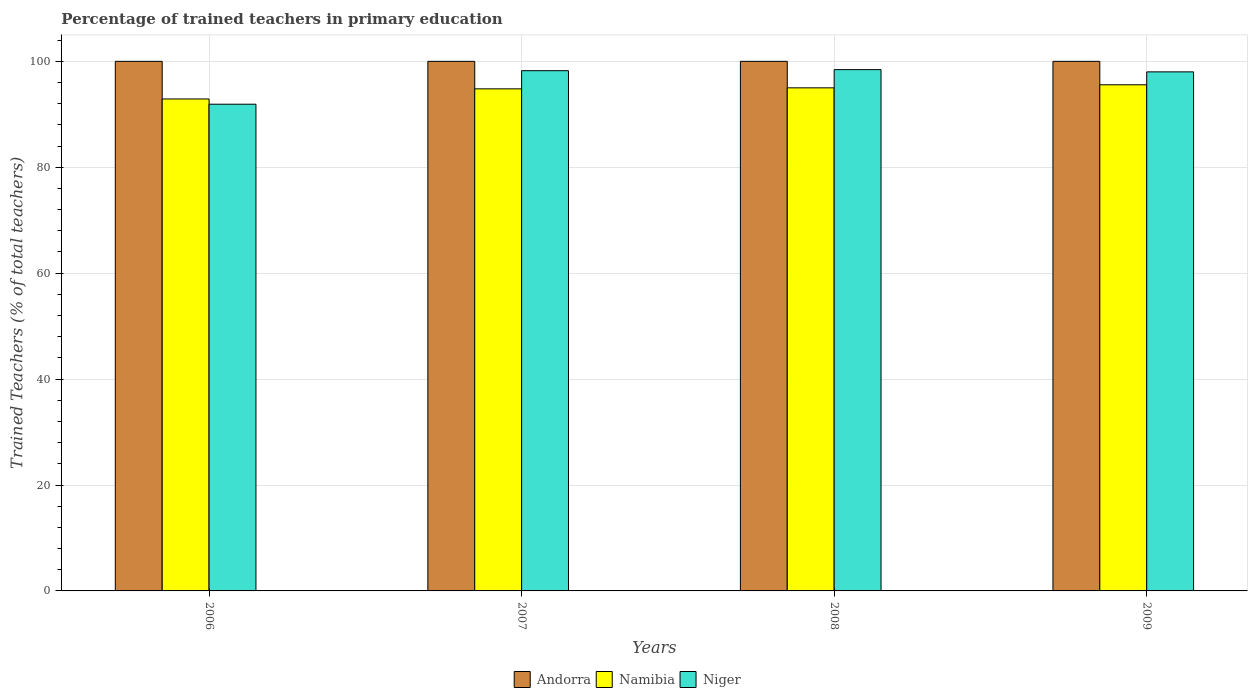How many different coloured bars are there?
Your answer should be very brief. 3. Are the number of bars on each tick of the X-axis equal?
Your response must be concise. Yes. What is the label of the 1st group of bars from the left?
Keep it short and to the point. 2006. In how many cases, is the number of bars for a given year not equal to the number of legend labels?
Offer a very short reply. 0. What is the percentage of trained teachers in Namibia in 2009?
Your response must be concise. 95.58. Across all years, what is the maximum percentage of trained teachers in Andorra?
Make the answer very short. 100. Across all years, what is the minimum percentage of trained teachers in Andorra?
Offer a terse response. 100. What is the total percentage of trained teachers in Namibia in the graph?
Your answer should be very brief. 378.28. What is the difference between the percentage of trained teachers in Namibia in 2007 and the percentage of trained teachers in Andorra in 2006?
Your answer should be compact. -5.19. What is the average percentage of trained teachers in Namibia per year?
Your answer should be very brief. 94.57. In the year 2006, what is the difference between the percentage of trained teachers in Andorra and percentage of trained teachers in Namibia?
Provide a succinct answer. 7.1. What is the ratio of the percentage of trained teachers in Namibia in 2007 to that in 2009?
Your answer should be very brief. 0.99. Is the percentage of trained teachers in Andorra in 2007 less than that in 2008?
Your answer should be compact. No. What is the difference between the highest and the second highest percentage of trained teachers in Andorra?
Offer a very short reply. 0. What is the difference between the highest and the lowest percentage of trained teachers in Andorra?
Give a very brief answer. 0. What does the 3rd bar from the left in 2006 represents?
Your answer should be compact. Niger. What does the 3rd bar from the right in 2007 represents?
Make the answer very short. Andorra. Is it the case that in every year, the sum of the percentage of trained teachers in Niger and percentage of trained teachers in Namibia is greater than the percentage of trained teachers in Andorra?
Provide a succinct answer. Yes. How many bars are there?
Make the answer very short. 12. Are all the bars in the graph horizontal?
Provide a succinct answer. No. How many years are there in the graph?
Make the answer very short. 4. Are the values on the major ticks of Y-axis written in scientific E-notation?
Your response must be concise. No. How are the legend labels stacked?
Your response must be concise. Horizontal. What is the title of the graph?
Your answer should be very brief. Percentage of trained teachers in primary education. Does "Zimbabwe" appear as one of the legend labels in the graph?
Provide a succinct answer. No. What is the label or title of the Y-axis?
Your response must be concise. Trained Teachers (% of total teachers). What is the Trained Teachers (% of total teachers) in Namibia in 2006?
Your answer should be compact. 92.9. What is the Trained Teachers (% of total teachers) in Niger in 2006?
Ensure brevity in your answer.  91.91. What is the Trained Teachers (% of total teachers) of Namibia in 2007?
Keep it short and to the point. 94.81. What is the Trained Teachers (% of total teachers) of Niger in 2007?
Provide a succinct answer. 98.24. What is the Trained Teachers (% of total teachers) of Namibia in 2008?
Provide a succinct answer. 95. What is the Trained Teachers (% of total teachers) of Niger in 2008?
Provide a succinct answer. 98.44. What is the Trained Teachers (% of total teachers) in Namibia in 2009?
Offer a very short reply. 95.58. What is the Trained Teachers (% of total teachers) in Niger in 2009?
Your answer should be compact. 98.01. Across all years, what is the maximum Trained Teachers (% of total teachers) of Andorra?
Your response must be concise. 100. Across all years, what is the maximum Trained Teachers (% of total teachers) of Namibia?
Give a very brief answer. 95.58. Across all years, what is the maximum Trained Teachers (% of total teachers) of Niger?
Keep it short and to the point. 98.44. Across all years, what is the minimum Trained Teachers (% of total teachers) of Namibia?
Make the answer very short. 92.9. Across all years, what is the minimum Trained Teachers (% of total teachers) in Niger?
Make the answer very short. 91.91. What is the total Trained Teachers (% of total teachers) of Andorra in the graph?
Ensure brevity in your answer.  400. What is the total Trained Teachers (% of total teachers) in Namibia in the graph?
Keep it short and to the point. 378.28. What is the total Trained Teachers (% of total teachers) in Niger in the graph?
Offer a very short reply. 386.6. What is the difference between the Trained Teachers (% of total teachers) in Namibia in 2006 and that in 2007?
Provide a succinct answer. -1.91. What is the difference between the Trained Teachers (% of total teachers) in Niger in 2006 and that in 2007?
Offer a very short reply. -6.33. What is the difference between the Trained Teachers (% of total teachers) of Andorra in 2006 and that in 2008?
Your response must be concise. 0. What is the difference between the Trained Teachers (% of total teachers) in Namibia in 2006 and that in 2008?
Provide a succinct answer. -2.1. What is the difference between the Trained Teachers (% of total teachers) in Niger in 2006 and that in 2008?
Offer a very short reply. -6.53. What is the difference between the Trained Teachers (% of total teachers) in Namibia in 2006 and that in 2009?
Offer a terse response. -2.68. What is the difference between the Trained Teachers (% of total teachers) in Niger in 2006 and that in 2009?
Provide a succinct answer. -6.11. What is the difference between the Trained Teachers (% of total teachers) of Namibia in 2007 and that in 2008?
Keep it short and to the point. -0.19. What is the difference between the Trained Teachers (% of total teachers) in Niger in 2007 and that in 2008?
Your response must be concise. -0.2. What is the difference between the Trained Teachers (% of total teachers) of Namibia in 2007 and that in 2009?
Give a very brief answer. -0.77. What is the difference between the Trained Teachers (% of total teachers) in Niger in 2007 and that in 2009?
Offer a terse response. 0.22. What is the difference between the Trained Teachers (% of total teachers) of Namibia in 2008 and that in 2009?
Ensure brevity in your answer.  -0.58. What is the difference between the Trained Teachers (% of total teachers) in Niger in 2008 and that in 2009?
Give a very brief answer. 0.42. What is the difference between the Trained Teachers (% of total teachers) of Andorra in 2006 and the Trained Teachers (% of total teachers) of Namibia in 2007?
Keep it short and to the point. 5.19. What is the difference between the Trained Teachers (% of total teachers) of Andorra in 2006 and the Trained Teachers (% of total teachers) of Niger in 2007?
Ensure brevity in your answer.  1.76. What is the difference between the Trained Teachers (% of total teachers) of Namibia in 2006 and the Trained Teachers (% of total teachers) of Niger in 2007?
Provide a short and direct response. -5.34. What is the difference between the Trained Teachers (% of total teachers) of Andorra in 2006 and the Trained Teachers (% of total teachers) of Namibia in 2008?
Make the answer very short. 5. What is the difference between the Trained Teachers (% of total teachers) in Andorra in 2006 and the Trained Teachers (% of total teachers) in Niger in 2008?
Give a very brief answer. 1.56. What is the difference between the Trained Teachers (% of total teachers) of Namibia in 2006 and the Trained Teachers (% of total teachers) of Niger in 2008?
Provide a succinct answer. -5.54. What is the difference between the Trained Teachers (% of total teachers) of Andorra in 2006 and the Trained Teachers (% of total teachers) of Namibia in 2009?
Offer a terse response. 4.42. What is the difference between the Trained Teachers (% of total teachers) of Andorra in 2006 and the Trained Teachers (% of total teachers) of Niger in 2009?
Give a very brief answer. 1.99. What is the difference between the Trained Teachers (% of total teachers) in Namibia in 2006 and the Trained Teachers (% of total teachers) in Niger in 2009?
Ensure brevity in your answer.  -5.12. What is the difference between the Trained Teachers (% of total teachers) in Andorra in 2007 and the Trained Teachers (% of total teachers) in Namibia in 2008?
Your answer should be compact. 5. What is the difference between the Trained Teachers (% of total teachers) in Andorra in 2007 and the Trained Teachers (% of total teachers) in Niger in 2008?
Offer a terse response. 1.56. What is the difference between the Trained Teachers (% of total teachers) in Namibia in 2007 and the Trained Teachers (% of total teachers) in Niger in 2008?
Keep it short and to the point. -3.63. What is the difference between the Trained Teachers (% of total teachers) in Andorra in 2007 and the Trained Teachers (% of total teachers) in Namibia in 2009?
Keep it short and to the point. 4.42. What is the difference between the Trained Teachers (% of total teachers) of Andorra in 2007 and the Trained Teachers (% of total teachers) of Niger in 2009?
Offer a very short reply. 1.99. What is the difference between the Trained Teachers (% of total teachers) in Namibia in 2007 and the Trained Teachers (% of total teachers) in Niger in 2009?
Provide a succinct answer. -3.21. What is the difference between the Trained Teachers (% of total teachers) of Andorra in 2008 and the Trained Teachers (% of total teachers) of Namibia in 2009?
Make the answer very short. 4.42. What is the difference between the Trained Teachers (% of total teachers) in Andorra in 2008 and the Trained Teachers (% of total teachers) in Niger in 2009?
Your response must be concise. 1.99. What is the difference between the Trained Teachers (% of total teachers) of Namibia in 2008 and the Trained Teachers (% of total teachers) of Niger in 2009?
Your answer should be very brief. -3.02. What is the average Trained Teachers (% of total teachers) in Namibia per year?
Offer a very short reply. 94.57. What is the average Trained Teachers (% of total teachers) in Niger per year?
Keep it short and to the point. 96.65. In the year 2006, what is the difference between the Trained Teachers (% of total teachers) of Andorra and Trained Teachers (% of total teachers) of Namibia?
Offer a very short reply. 7.1. In the year 2006, what is the difference between the Trained Teachers (% of total teachers) of Andorra and Trained Teachers (% of total teachers) of Niger?
Your answer should be very brief. 8.09. In the year 2006, what is the difference between the Trained Teachers (% of total teachers) in Namibia and Trained Teachers (% of total teachers) in Niger?
Provide a short and direct response. 0.99. In the year 2007, what is the difference between the Trained Teachers (% of total teachers) in Andorra and Trained Teachers (% of total teachers) in Namibia?
Offer a very short reply. 5.19. In the year 2007, what is the difference between the Trained Teachers (% of total teachers) in Andorra and Trained Teachers (% of total teachers) in Niger?
Your answer should be very brief. 1.76. In the year 2007, what is the difference between the Trained Teachers (% of total teachers) in Namibia and Trained Teachers (% of total teachers) in Niger?
Give a very brief answer. -3.43. In the year 2008, what is the difference between the Trained Teachers (% of total teachers) of Andorra and Trained Teachers (% of total teachers) of Namibia?
Your answer should be very brief. 5. In the year 2008, what is the difference between the Trained Teachers (% of total teachers) of Andorra and Trained Teachers (% of total teachers) of Niger?
Ensure brevity in your answer.  1.56. In the year 2008, what is the difference between the Trained Teachers (% of total teachers) in Namibia and Trained Teachers (% of total teachers) in Niger?
Keep it short and to the point. -3.44. In the year 2009, what is the difference between the Trained Teachers (% of total teachers) in Andorra and Trained Teachers (% of total teachers) in Namibia?
Your response must be concise. 4.42. In the year 2009, what is the difference between the Trained Teachers (% of total teachers) of Andorra and Trained Teachers (% of total teachers) of Niger?
Make the answer very short. 1.99. In the year 2009, what is the difference between the Trained Teachers (% of total teachers) of Namibia and Trained Teachers (% of total teachers) of Niger?
Your answer should be compact. -2.44. What is the ratio of the Trained Teachers (% of total teachers) of Namibia in 2006 to that in 2007?
Your response must be concise. 0.98. What is the ratio of the Trained Teachers (% of total teachers) in Niger in 2006 to that in 2007?
Keep it short and to the point. 0.94. What is the ratio of the Trained Teachers (% of total teachers) in Andorra in 2006 to that in 2008?
Make the answer very short. 1. What is the ratio of the Trained Teachers (% of total teachers) of Namibia in 2006 to that in 2008?
Offer a very short reply. 0.98. What is the ratio of the Trained Teachers (% of total teachers) in Niger in 2006 to that in 2008?
Offer a very short reply. 0.93. What is the ratio of the Trained Teachers (% of total teachers) in Andorra in 2006 to that in 2009?
Provide a succinct answer. 1. What is the ratio of the Trained Teachers (% of total teachers) in Niger in 2006 to that in 2009?
Provide a short and direct response. 0.94. What is the ratio of the Trained Teachers (% of total teachers) in Andorra in 2007 to that in 2008?
Keep it short and to the point. 1. What is the ratio of the Trained Teachers (% of total teachers) of Andorra in 2007 to that in 2009?
Offer a terse response. 1. What is the difference between the highest and the second highest Trained Teachers (% of total teachers) in Andorra?
Give a very brief answer. 0. What is the difference between the highest and the second highest Trained Teachers (% of total teachers) of Namibia?
Provide a succinct answer. 0.58. What is the difference between the highest and the second highest Trained Teachers (% of total teachers) in Niger?
Provide a succinct answer. 0.2. What is the difference between the highest and the lowest Trained Teachers (% of total teachers) in Namibia?
Provide a short and direct response. 2.68. What is the difference between the highest and the lowest Trained Teachers (% of total teachers) in Niger?
Give a very brief answer. 6.53. 